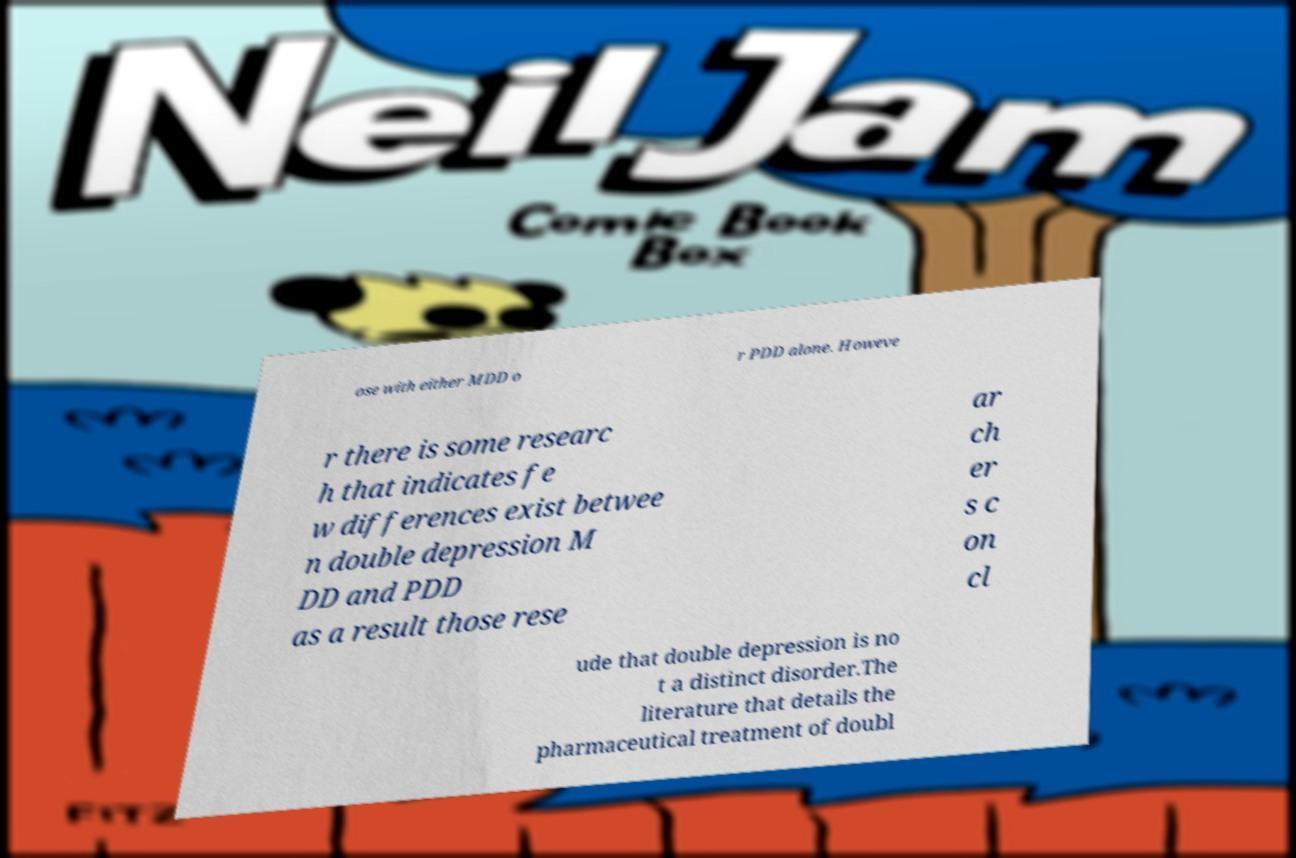I need the written content from this picture converted into text. Can you do that? ose with either MDD o r PDD alone. Howeve r there is some researc h that indicates fe w differences exist betwee n double depression M DD and PDD as a result those rese ar ch er s c on cl ude that double depression is no t a distinct disorder.The literature that details the pharmaceutical treatment of doubl 